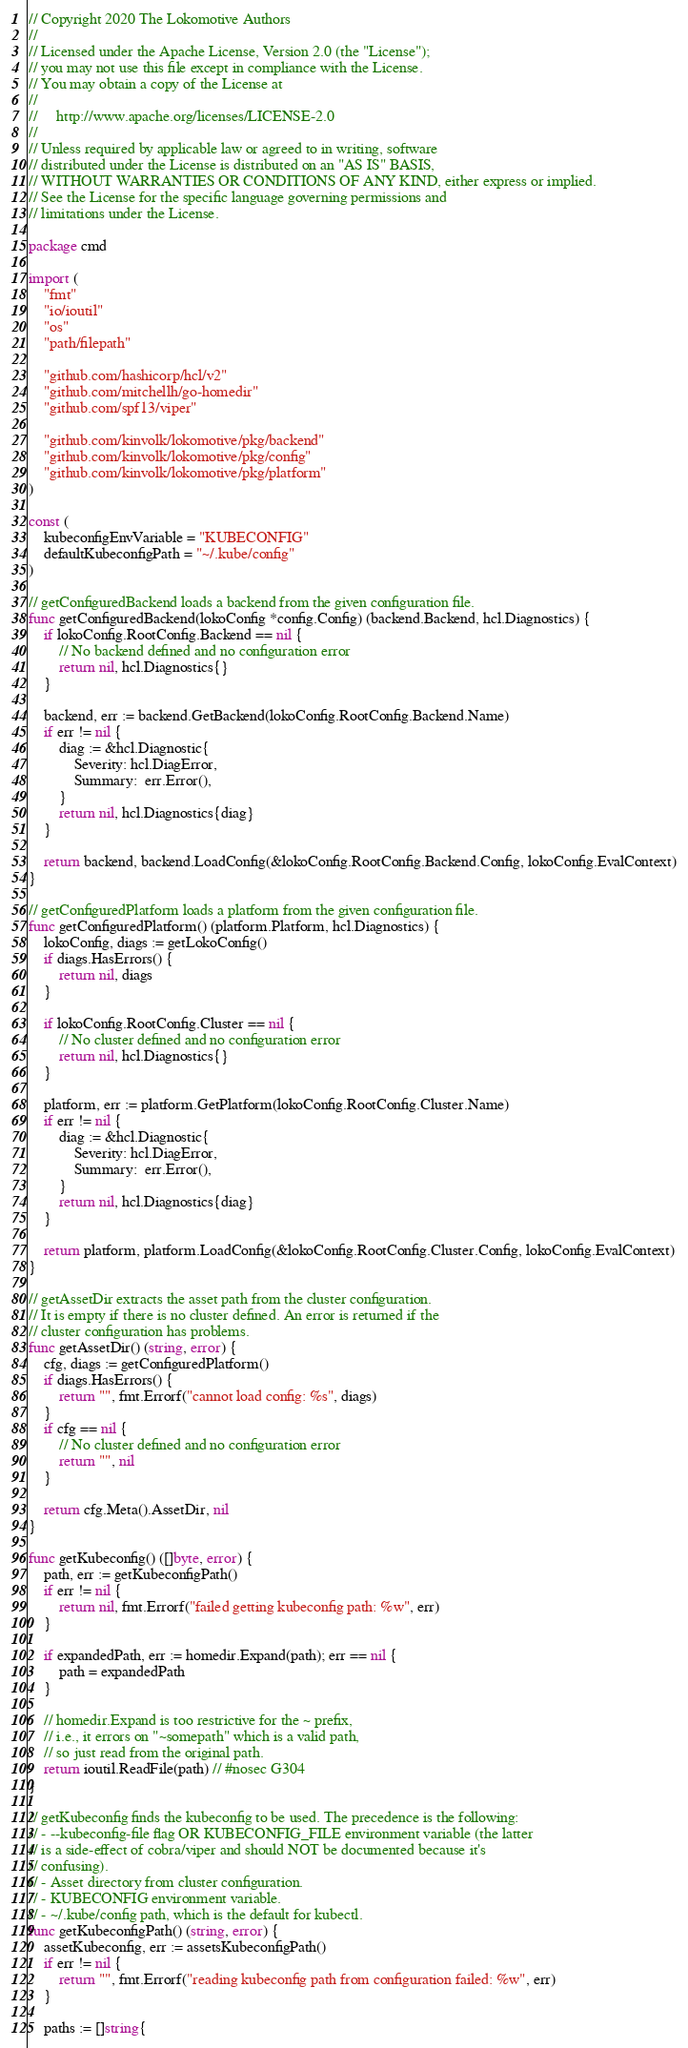Convert code to text. <code><loc_0><loc_0><loc_500><loc_500><_Go_>// Copyright 2020 The Lokomotive Authors
//
// Licensed under the Apache License, Version 2.0 (the "License");
// you may not use this file except in compliance with the License.
// You may obtain a copy of the License at
//
//     http://www.apache.org/licenses/LICENSE-2.0
//
// Unless required by applicable law or agreed to in writing, software
// distributed under the License is distributed on an "AS IS" BASIS,
// WITHOUT WARRANTIES OR CONDITIONS OF ANY KIND, either express or implied.
// See the License for the specific language governing permissions and
// limitations under the License.

package cmd

import (
	"fmt"
	"io/ioutil"
	"os"
	"path/filepath"

	"github.com/hashicorp/hcl/v2"
	"github.com/mitchellh/go-homedir"
	"github.com/spf13/viper"

	"github.com/kinvolk/lokomotive/pkg/backend"
	"github.com/kinvolk/lokomotive/pkg/config"
	"github.com/kinvolk/lokomotive/pkg/platform"
)

const (
	kubeconfigEnvVariable = "KUBECONFIG"
	defaultKubeconfigPath = "~/.kube/config"
)

// getConfiguredBackend loads a backend from the given configuration file.
func getConfiguredBackend(lokoConfig *config.Config) (backend.Backend, hcl.Diagnostics) {
	if lokoConfig.RootConfig.Backend == nil {
		// No backend defined and no configuration error
		return nil, hcl.Diagnostics{}
	}

	backend, err := backend.GetBackend(lokoConfig.RootConfig.Backend.Name)
	if err != nil {
		diag := &hcl.Diagnostic{
			Severity: hcl.DiagError,
			Summary:  err.Error(),
		}
		return nil, hcl.Diagnostics{diag}
	}

	return backend, backend.LoadConfig(&lokoConfig.RootConfig.Backend.Config, lokoConfig.EvalContext)
}

// getConfiguredPlatform loads a platform from the given configuration file.
func getConfiguredPlatform() (platform.Platform, hcl.Diagnostics) {
	lokoConfig, diags := getLokoConfig()
	if diags.HasErrors() {
		return nil, diags
	}

	if lokoConfig.RootConfig.Cluster == nil {
		// No cluster defined and no configuration error
		return nil, hcl.Diagnostics{}
	}

	platform, err := platform.GetPlatform(lokoConfig.RootConfig.Cluster.Name)
	if err != nil {
		diag := &hcl.Diagnostic{
			Severity: hcl.DiagError,
			Summary:  err.Error(),
		}
		return nil, hcl.Diagnostics{diag}
	}

	return platform, platform.LoadConfig(&lokoConfig.RootConfig.Cluster.Config, lokoConfig.EvalContext)
}

// getAssetDir extracts the asset path from the cluster configuration.
// It is empty if there is no cluster defined. An error is returned if the
// cluster configuration has problems.
func getAssetDir() (string, error) {
	cfg, diags := getConfiguredPlatform()
	if diags.HasErrors() {
		return "", fmt.Errorf("cannot load config: %s", diags)
	}
	if cfg == nil {
		// No cluster defined and no configuration error
		return "", nil
	}

	return cfg.Meta().AssetDir, nil
}

func getKubeconfig() ([]byte, error) {
	path, err := getKubeconfigPath()
	if err != nil {
		return nil, fmt.Errorf("failed getting kubeconfig path: %w", err)
	}

	if expandedPath, err := homedir.Expand(path); err == nil {
		path = expandedPath
	}

	// homedir.Expand is too restrictive for the ~ prefix,
	// i.e., it errors on "~somepath" which is a valid path,
	// so just read from the original path.
	return ioutil.ReadFile(path) // #nosec G304
}

// getKubeconfig finds the kubeconfig to be used. The precedence is the following:
// - --kubeconfig-file flag OR KUBECONFIG_FILE environment variable (the latter
// is a side-effect of cobra/viper and should NOT be documented because it's
// confusing).
// - Asset directory from cluster configuration.
// - KUBECONFIG environment variable.
// - ~/.kube/config path, which is the default for kubectl.
func getKubeconfigPath() (string, error) {
	assetKubeconfig, err := assetsKubeconfigPath()
	if err != nil {
		return "", fmt.Errorf("reading kubeconfig path from configuration failed: %w", err)
	}

	paths := []string{</code> 